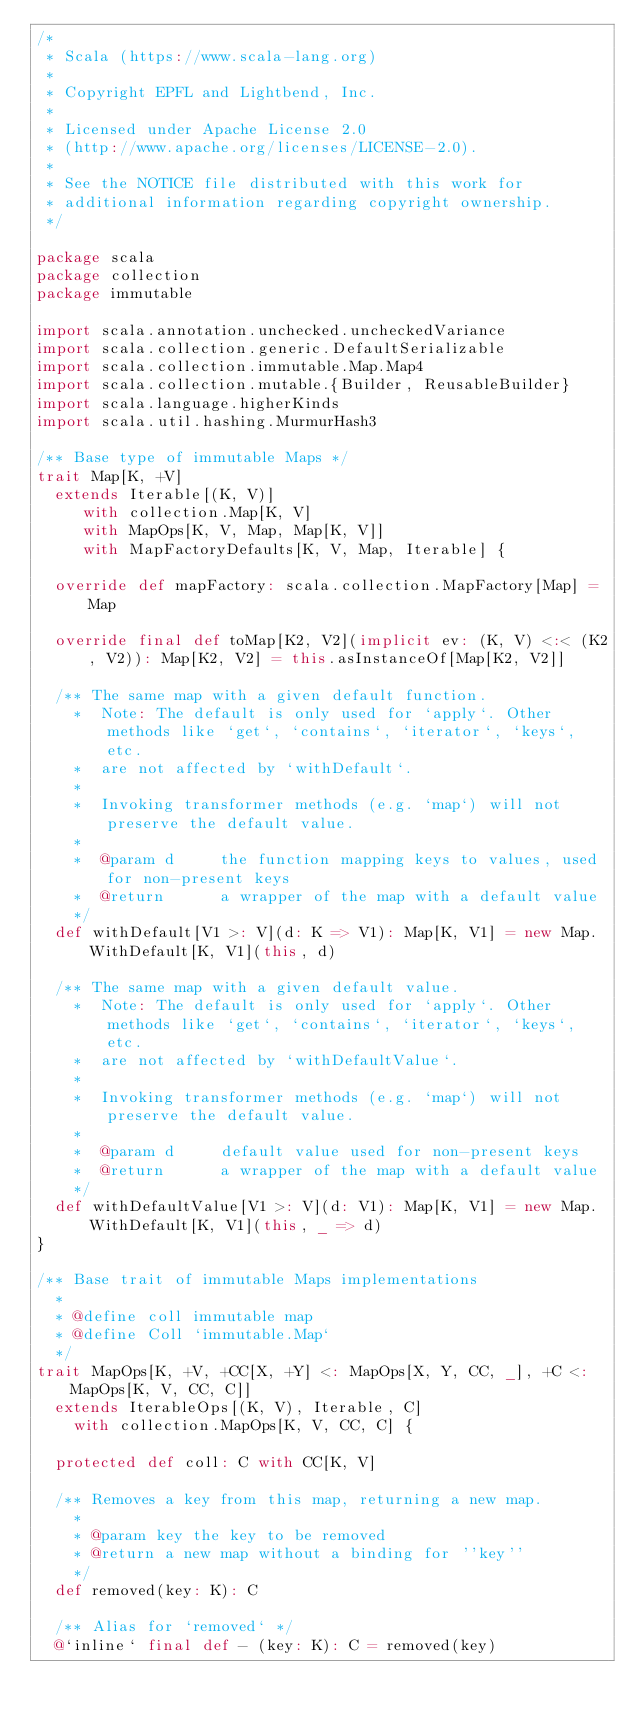<code> <loc_0><loc_0><loc_500><loc_500><_Scala_>/*
 * Scala (https://www.scala-lang.org)
 *
 * Copyright EPFL and Lightbend, Inc.
 *
 * Licensed under Apache License 2.0
 * (http://www.apache.org/licenses/LICENSE-2.0).
 *
 * See the NOTICE file distributed with this work for
 * additional information regarding copyright ownership.
 */

package scala
package collection
package immutable

import scala.annotation.unchecked.uncheckedVariance
import scala.collection.generic.DefaultSerializable
import scala.collection.immutable.Map.Map4
import scala.collection.mutable.{Builder, ReusableBuilder}
import scala.language.higherKinds
import scala.util.hashing.MurmurHash3

/** Base type of immutable Maps */
trait Map[K, +V]
  extends Iterable[(K, V)]
     with collection.Map[K, V]
     with MapOps[K, V, Map, Map[K, V]]
     with MapFactoryDefaults[K, V, Map, Iterable] {

  override def mapFactory: scala.collection.MapFactory[Map] = Map

  override final def toMap[K2, V2](implicit ev: (K, V) <:< (K2, V2)): Map[K2, V2] = this.asInstanceOf[Map[K2, V2]]

  /** The same map with a given default function.
    *  Note: The default is only used for `apply`. Other methods like `get`, `contains`, `iterator`, `keys`, etc.
    *  are not affected by `withDefault`.
    *
    *  Invoking transformer methods (e.g. `map`) will not preserve the default value.
    *
    *  @param d     the function mapping keys to values, used for non-present keys
    *  @return      a wrapper of the map with a default value
    */
  def withDefault[V1 >: V](d: K => V1): Map[K, V1] = new Map.WithDefault[K, V1](this, d)

  /** The same map with a given default value.
    *  Note: The default is only used for `apply`. Other methods like `get`, `contains`, `iterator`, `keys`, etc.
    *  are not affected by `withDefaultValue`.
    *
    *  Invoking transformer methods (e.g. `map`) will not preserve the default value.
    *
    *  @param d     default value used for non-present keys
    *  @return      a wrapper of the map with a default value
    */
  def withDefaultValue[V1 >: V](d: V1): Map[K, V1] = new Map.WithDefault[K, V1](this, _ => d)
}

/** Base trait of immutable Maps implementations
  *
  * @define coll immutable map
  * @define Coll `immutable.Map`
  */
trait MapOps[K, +V, +CC[X, +Y] <: MapOps[X, Y, CC, _], +C <: MapOps[K, V, CC, C]]
  extends IterableOps[(K, V), Iterable, C]
    with collection.MapOps[K, V, CC, C] {

  protected def coll: C with CC[K, V]

  /** Removes a key from this map, returning a new map.
    *
    * @param key the key to be removed
    * @return a new map without a binding for ''key''
    */
  def removed(key: K): C

  /** Alias for `removed` */
  @`inline` final def - (key: K): C = removed(key)
</code> 